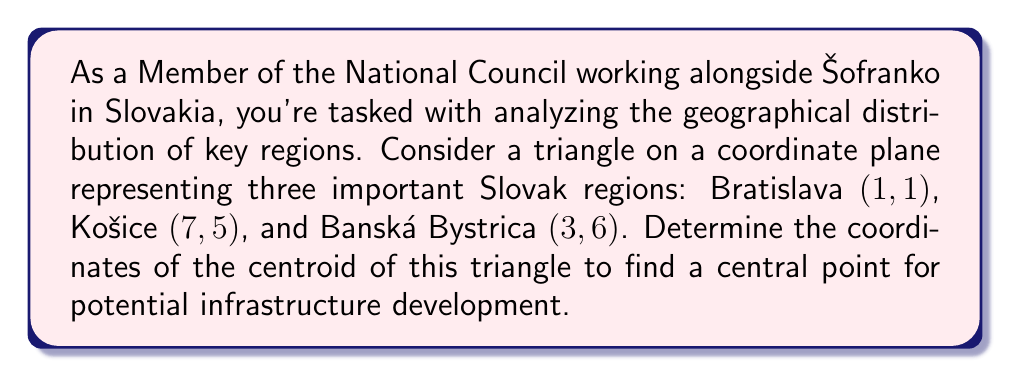What is the answer to this math problem? To solve this problem, we'll follow these steps:

1) The centroid of a triangle is located at the intersection of its medians. It can be calculated as the average of the x-coordinates and y-coordinates of the three vertices.

2) Let's define our points:
   Bratislava: $(x_1, y_1) = (1, 1)$
   Košice: $(x_2, y_2) = (7, 5)$
   Banská Bystrica: $(x_3, y_3) = (3, 6)$

3) The formula for the centroid $(x_c, y_c)$ is:

   $$x_c = \frac{x_1 + x_2 + x_3}{3}$$
   $$y_c = \frac{y_1 + y_2 + y_3}{3}$$

4) Let's calculate $x_c$:
   $$x_c = \frac{1 + 7 + 3}{3} = \frac{11}{3} \approx 3.67$$

5) Now, let's calculate $y_c$:
   $$y_c = \frac{1 + 5 + 6}{3} = \frac{12}{3} = 4$$

6) Therefore, the centroid is located at $(\frac{11}{3}, 4)$ or approximately $(3.67, 4)$.

[asy]
import geometry;

size(200);
dot((1,1),red);
dot((7,5),red);
dot((3,6),red);
dot((11/3,4),blue);

label("Bratislava (1,1)", (1,1), SW);
label("Košice (7,5)", (7,5), NE);
label("Banská Bystrica (3,6)", (3,6), NW);
label("Centroid (11/3,4)", (11/3,4), SE);

draw((1,1)--(7,5)--(3,6)--cycle);
[/asy]
Answer: The coordinates of the centroid are $(\frac{11}{3}, 4)$ or approximately $(3.67, 4)$. 